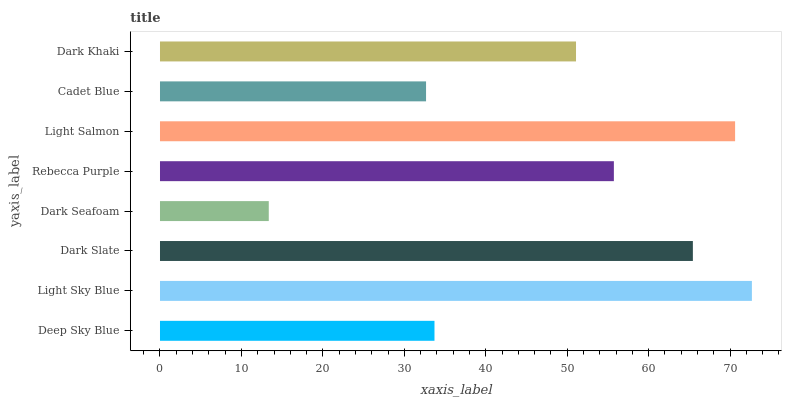Is Dark Seafoam the minimum?
Answer yes or no. Yes. Is Light Sky Blue the maximum?
Answer yes or no. Yes. Is Dark Slate the minimum?
Answer yes or no. No. Is Dark Slate the maximum?
Answer yes or no. No. Is Light Sky Blue greater than Dark Slate?
Answer yes or no. Yes. Is Dark Slate less than Light Sky Blue?
Answer yes or no. Yes. Is Dark Slate greater than Light Sky Blue?
Answer yes or no. No. Is Light Sky Blue less than Dark Slate?
Answer yes or no. No. Is Rebecca Purple the high median?
Answer yes or no. Yes. Is Dark Khaki the low median?
Answer yes or no. Yes. Is Light Sky Blue the high median?
Answer yes or no. No. Is Deep Sky Blue the low median?
Answer yes or no. No. 